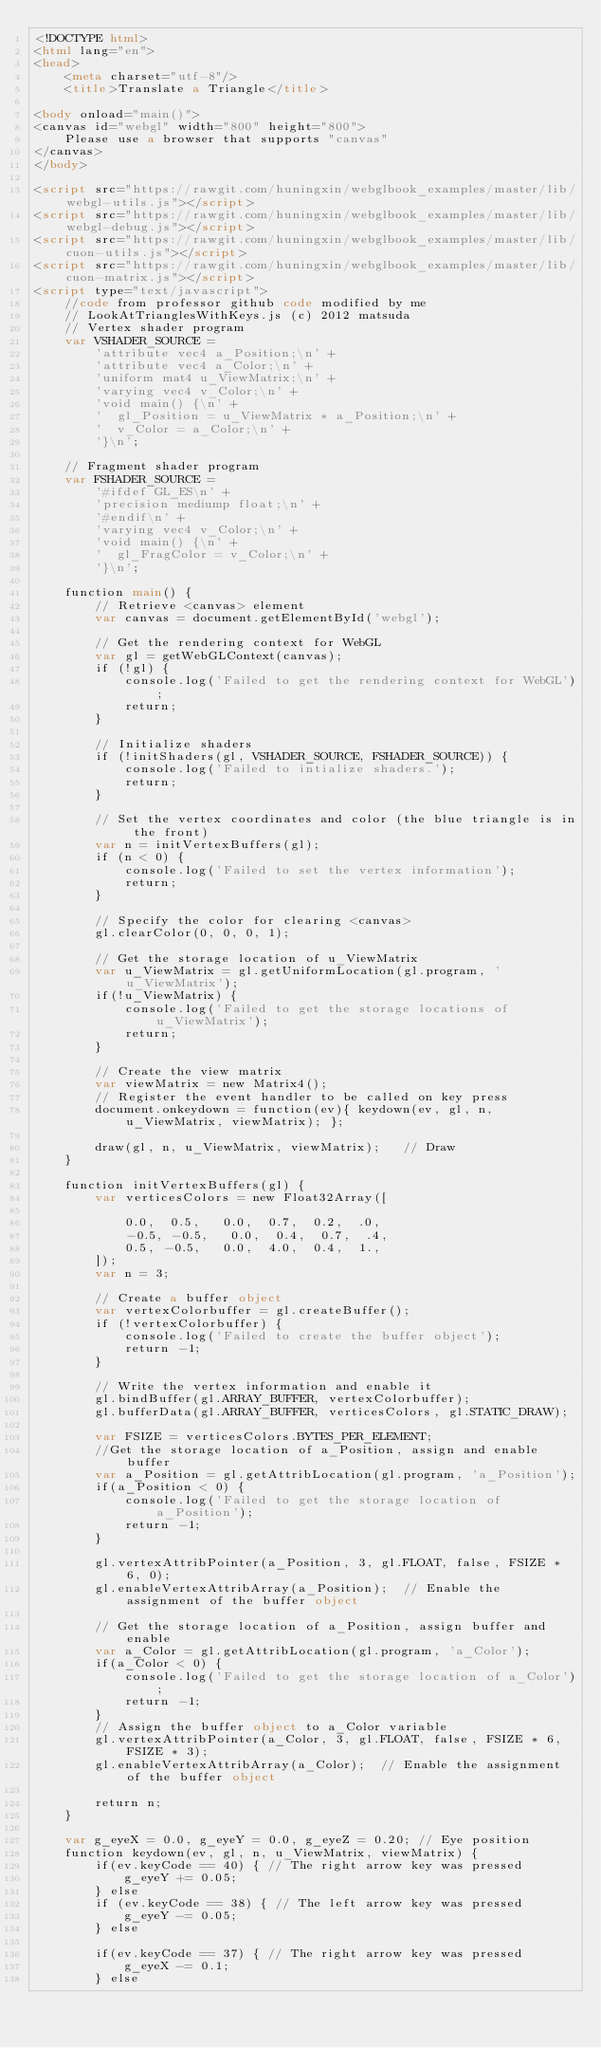Convert code to text. <code><loc_0><loc_0><loc_500><loc_500><_HTML_><!DOCTYPE html>
<html lang="en">
<head>
    <meta charset="utf-8"/>
    <title>Translate a Triangle</title>

<body onload="main()">
<canvas id="webgl" width="800" height="800">
    Please use a browser that supports "canvas"
</canvas>
</body>

<script src="https://rawgit.com/huningxin/webglbook_examples/master/lib/webgl-utils.js"></script>
<script src="https://rawgit.com/huningxin/webglbook_examples/master/lib/webgl-debug.js"></script>
<script src="https://rawgit.com/huningxin/webglbook_examples/master/lib/cuon-utils.js"></script>
<script src="https://rawgit.com/huningxin/webglbook_examples/master/lib/cuon-matrix.js"></script>
<script type="text/javascript">
    //code from professor github code modified by me
    // LookAtTrianglesWithKeys.js (c) 2012 matsuda
    // Vertex shader program
    var VSHADER_SOURCE =
        'attribute vec4 a_Position;\n' +
        'attribute vec4 a_Color;\n' +
        'uniform mat4 u_ViewMatrix;\n' +
        'varying vec4 v_Color;\n' +
        'void main() {\n' +
        '  gl_Position = u_ViewMatrix * a_Position;\n' +
        '  v_Color = a_Color;\n' +
        '}\n';

    // Fragment shader program
    var FSHADER_SOURCE =
        '#ifdef GL_ES\n' +
        'precision mediump float;\n' +
        '#endif\n' +
        'varying vec4 v_Color;\n' +
        'void main() {\n' +
        '  gl_FragColor = v_Color;\n' +
        '}\n';

    function main() {
        // Retrieve <canvas> element
        var canvas = document.getElementById('webgl');

        // Get the rendering context for WebGL
        var gl = getWebGLContext(canvas);
        if (!gl) {
            console.log('Failed to get the rendering context for WebGL');
            return;
        }

        // Initialize shaders
        if (!initShaders(gl, VSHADER_SOURCE, FSHADER_SOURCE)) {
            console.log('Failed to intialize shaders.');
            return;
        }

        // Set the vertex coordinates and color (the blue triangle is in the front)
        var n = initVertexBuffers(gl);
        if (n < 0) {
            console.log('Failed to set the vertex information');
            return;
        }

        // Specify the color for clearing <canvas>
        gl.clearColor(0, 0, 0, 1);

        // Get the storage location of u_ViewMatrix
        var u_ViewMatrix = gl.getUniformLocation(gl.program, 'u_ViewMatrix');
        if(!u_ViewMatrix) {
            console.log('Failed to get the storage locations of u_ViewMatrix');
            return;
        }

        // Create the view matrix
        var viewMatrix = new Matrix4();
        // Register the event handler to be called on key press
        document.onkeydown = function(ev){ keydown(ev, gl, n, u_ViewMatrix, viewMatrix); };

        draw(gl, n, u_ViewMatrix, viewMatrix);   // Draw
    }

    function initVertexBuffers(gl) {
        var verticesColors = new Float32Array([

            0.0,  0.5,   0.0,  0.7,  0.2,  .0,
            -0.5, -0.5,   0.0,  0.4,  0.7,  .4,
            0.5, -0.5,   0.0,  4.0,  0.4,  1.,
        ]);
        var n = 3;

        // Create a buffer object
        var vertexColorbuffer = gl.createBuffer();
        if (!vertexColorbuffer) {
            console.log('Failed to create the buffer object');
            return -1;
        }

        // Write the vertex information and enable it
        gl.bindBuffer(gl.ARRAY_BUFFER, vertexColorbuffer);
        gl.bufferData(gl.ARRAY_BUFFER, verticesColors, gl.STATIC_DRAW);

        var FSIZE = verticesColors.BYTES_PER_ELEMENT;
        //Get the storage location of a_Position, assign and enable buffer
        var a_Position = gl.getAttribLocation(gl.program, 'a_Position');
        if(a_Position < 0) {
            console.log('Failed to get the storage location of a_Position');
            return -1;
        }

        gl.vertexAttribPointer(a_Position, 3, gl.FLOAT, false, FSIZE * 6, 0);
        gl.enableVertexAttribArray(a_Position);  // Enable the assignment of the buffer object

        // Get the storage location of a_Position, assign buffer and enable
        var a_Color = gl.getAttribLocation(gl.program, 'a_Color');
        if(a_Color < 0) {
            console.log('Failed to get the storage location of a_Color');
            return -1;
        }
        // Assign the buffer object to a_Color variable
        gl.vertexAttribPointer(a_Color, 3, gl.FLOAT, false, FSIZE * 6, FSIZE * 3);
        gl.enableVertexAttribArray(a_Color);  // Enable the assignment of the buffer object

        return n;
    }

    var g_eyeX = 0.0, g_eyeY = 0.0, g_eyeZ = 0.20; // Eye position
    function keydown(ev, gl, n, u_ViewMatrix, viewMatrix) {
        if(ev.keyCode == 40) { // The right arrow key was pressed
            g_eyeY += 0.05;
        } else
        if (ev.keyCode == 38) { // The left arrow key was pressed
            g_eyeY -= 0.05;
        } else

        if(ev.keyCode == 37) { // The right arrow key was pressed
            g_eyeX -= 0.1;
        } else</code> 